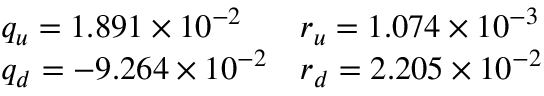Convert formula to latex. <formula><loc_0><loc_0><loc_500><loc_500>\begin{array} { l l } { { q _ { u } = 1 . 8 9 1 \times 1 0 ^ { - 2 } } } & { { r _ { u } = 1 . 0 7 4 \times 1 0 ^ { - 3 } } } \\ { { q _ { d } = - 9 . 2 6 4 \times 1 0 ^ { - 2 } } } & { { r _ { d } = 2 . 2 0 5 \times 1 0 ^ { - 2 } } } \end{array}</formula> 